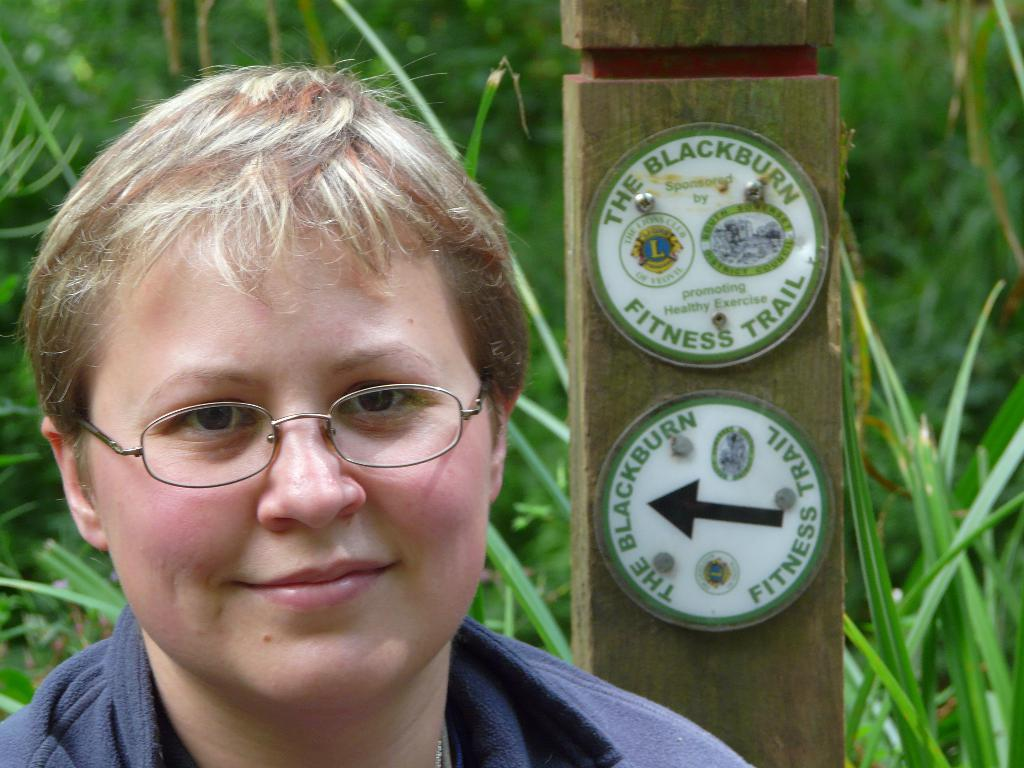What is the person in the image doing? The person is standing in the image. What expression does the person have? The person is smiling. What can be seen in the background of the image? There is a wooden plank in the background of the image. What type of natural environment is visible in the image? There is grass visible in the image. What type of tax is being discussed in the image? There is no discussion of tax in the image; it features a person standing and smiling with a wooden plank and grass in the background. What holiday is being celebrated in the image? There is no indication of a holiday being celebrated in the image. 